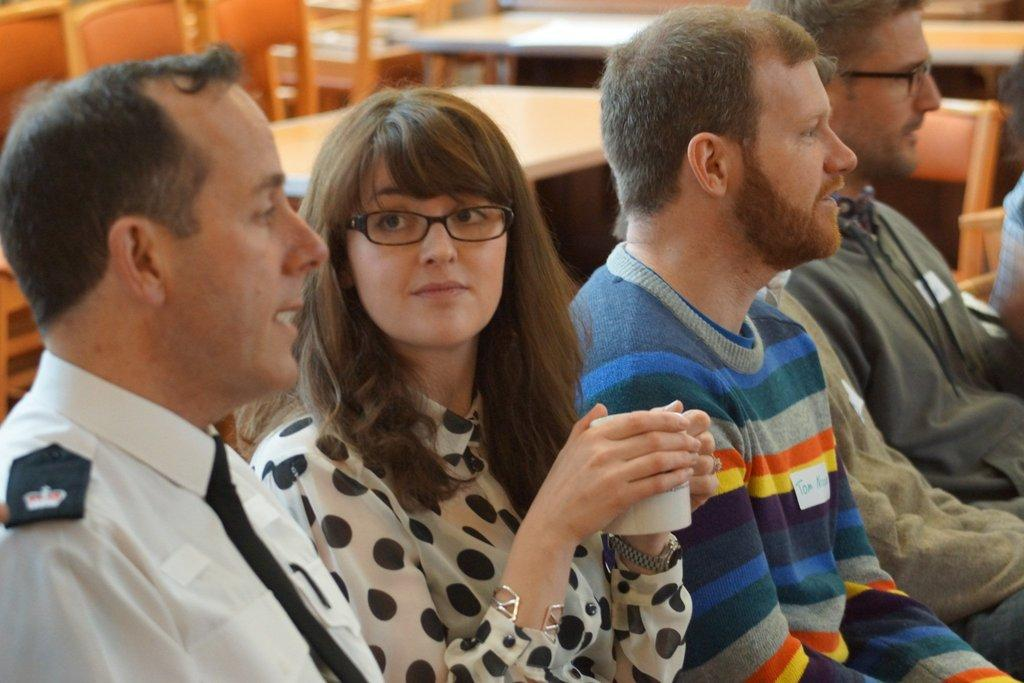What is the main subject of the image? The main subject of the image is a group of people. What can be seen in the background of the image? There are tables and chairs in the background of the image. How many sisters are sitting on the chairs in the image? There is no mention of sisters in the image, and the number of people sitting on the chairs cannot be determined from the provided facts. What type of nest can be seen in the image? There is no nest present in the image. 